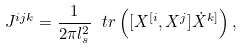<formula> <loc_0><loc_0><loc_500><loc_500>J ^ { i j k } = \frac { 1 } { 2 \pi l _ { s } ^ { 2 } } \ t r \left ( [ X ^ { [ i } , X ^ { j } ] \dot { X } ^ { k ] } \right ) ,</formula> 